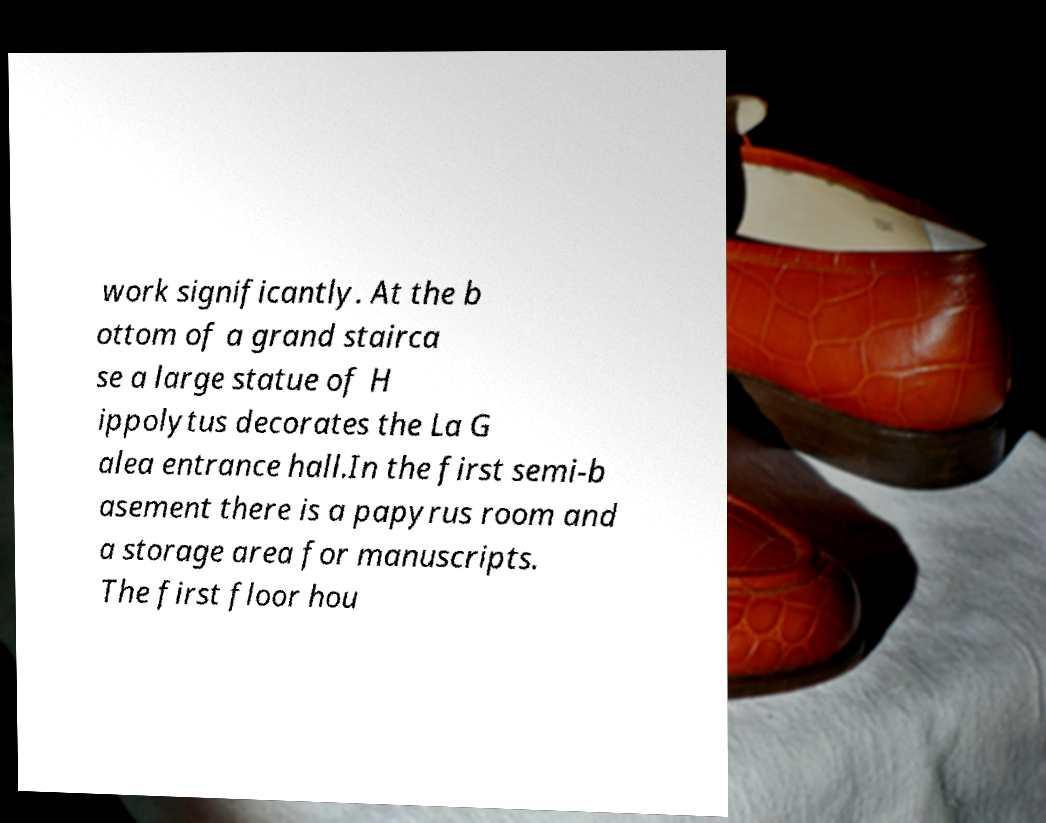Please read and relay the text visible in this image. What does it say? work significantly. At the b ottom of a grand stairca se a large statue of H ippolytus decorates the La G alea entrance hall.In the first semi-b asement there is a papyrus room and a storage area for manuscripts. The first floor hou 